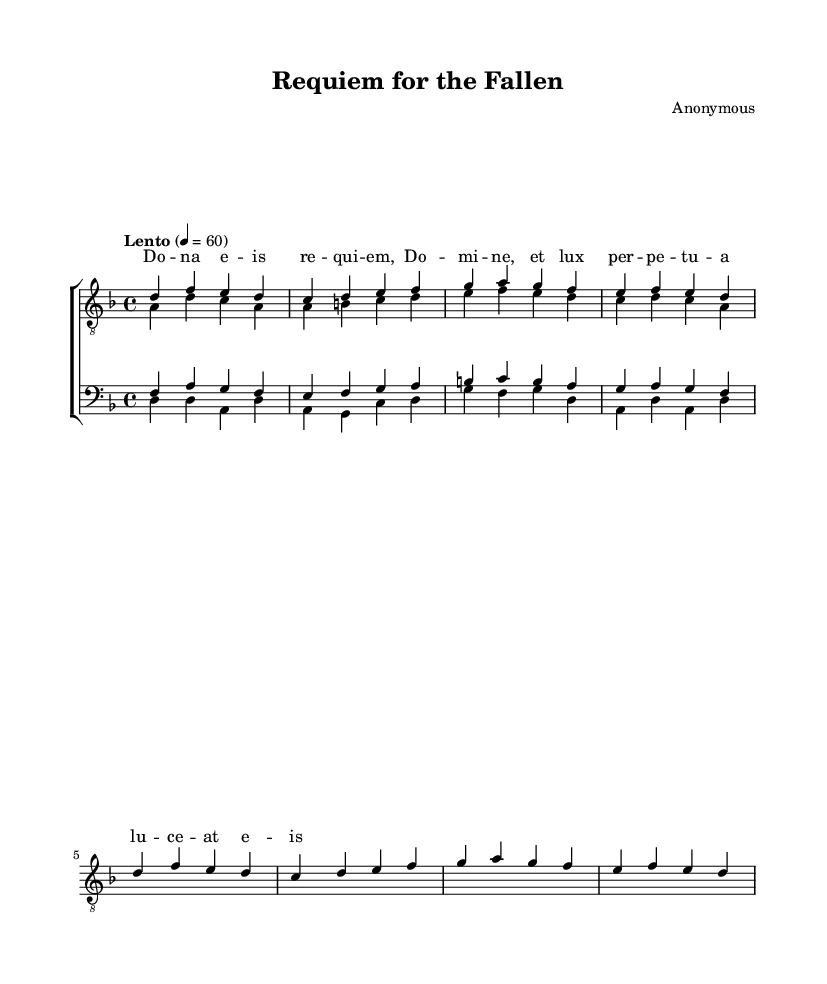What is the key signature of this music? The key signature is D minor, which has one flat (B flat). It can be identified by looking at the key signature marking at the beginning of the staff.
Answer: D minor What is the time signature of this music? The time signature is 4/4, indicated at the start of the music, which shows there are four beats in each measure and the quarter note receives one beat.
Answer: 4/4 What is the tempo marking of the piece? The tempo marking indicates "Lento," which translates to a slow pace. It is stated at the beginning, guiding performers on the speed of the music.
Answer: Lento How many staffs are used in this score? There are two staffs, one for tenors and one for basses, as indicated by the labels for each section at the beginning of the score.
Answer: Two Which vocal parts are included in this composition? The composition includes two tenor parts and two bass parts, clearly labeled as "tenors" and "basses" within the score.
Answer: Tenor One, Tenor Two, Bass One, Bass Two What kind of text is set to music in this piece? The text is a chant-style lyric often associated with religious themes, which can be deduced from the lyrics' solemn nature typified in a requiem.
Answer: Requiem 